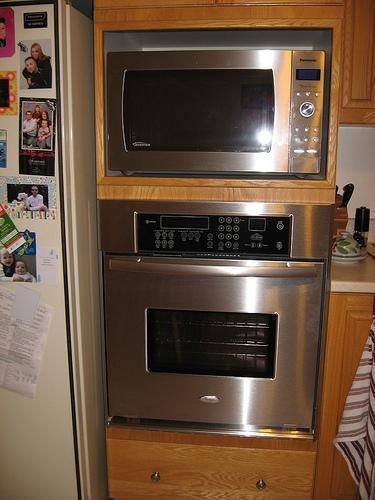How many items are of the same color?
Give a very brief answer. 2. How many people are cooking food?
Give a very brief answer. 0. 